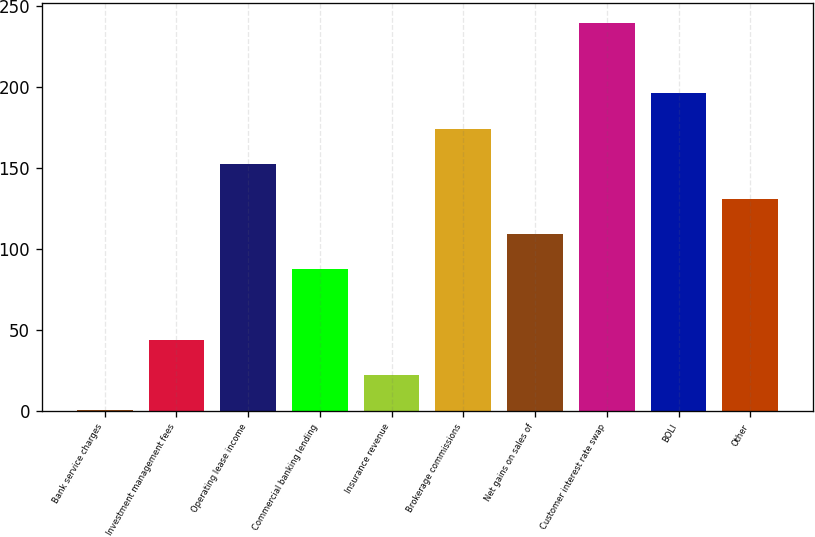Convert chart. <chart><loc_0><loc_0><loc_500><loc_500><bar_chart><fcel>Bank service charges<fcel>Investment management fees<fcel>Operating lease income<fcel>Commercial banking lending<fcel>Insurance revenue<fcel>Brokerage commissions<fcel>Net gains on sales of<fcel>Customer interest rate swap<fcel>BOLI<fcel>Other<nl><fcel>0.1<fcel>43.6<fcel>152.35<fcel>87.1<fcel>21.85<fcel>174.1<fcel>108.85<fcel>239.35<fcel>195.85<fcel>130.6<nl></chart> 